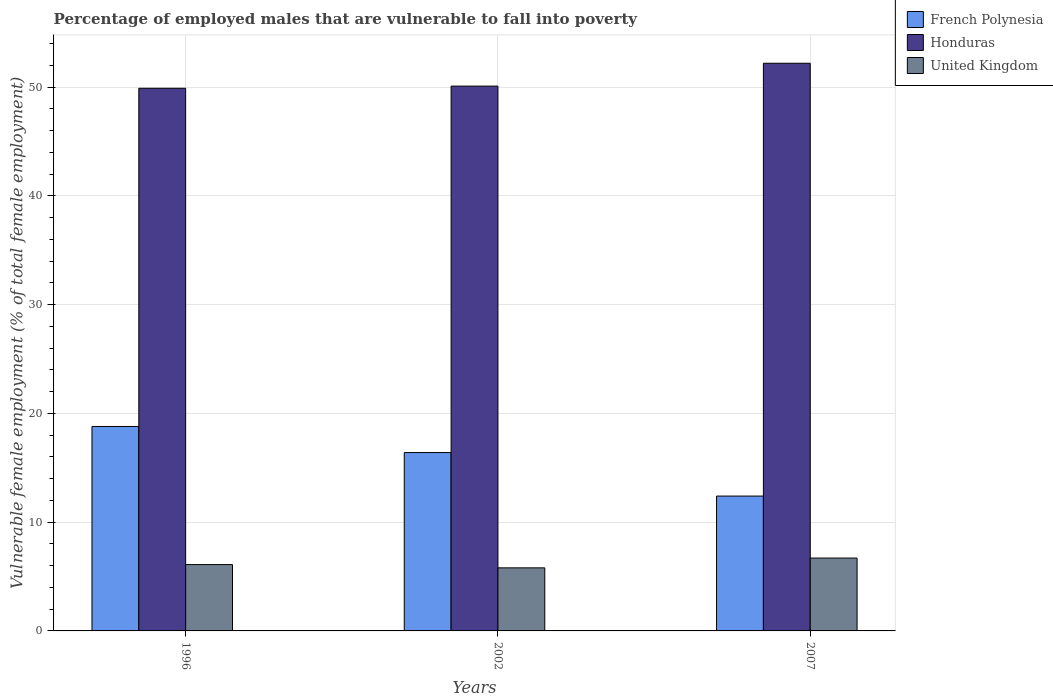How many groups of bars are there?
Your response must be concise. 3. Are the number of bars on each tick of the X-axis equal?
Make the answer very short. Yes. How many bars are there on the 2nd tick from the left?
Provide a short and direct response. 3. In how many cases, is the number of bars for a given year not equal to the number of legend labels?
Offer a terse response. 0. What is the percentage of employed males who are vulnerable to fall into poverty in Honduras in 2007?
Provide a short and direct response. 52.2. Across all years, what is the maximum percentage of employed males who are vulnerable to fall into poverty in Honduras?
Offer a terse response. 52.2. Across all years, what is the minimum percentage of employed males who are vulnerable to fall into poverty in French Polynesia?
Your answer should be compact. 12.4. In which year was the percentage of employed males who are vulnerable to fall into poverty in French Polynesia minimum?
Offer a very short reply. 2007. What is the total percentage of employed males who are vulnerable to fall into poverty in United Kingdom in the graph?
Your response must be concise. 18.6. What is the difference between the percentage of employed males who are vulnerable to fall into poverty in French Polynesia in 1996 and that in 2002?
Provide a succinct answer. 2.4. What is the difference between the percentage of employed males who are vulnerable to fall into poverty in French Polynesia in 2007 and the percentage of employed males who are vulnerable to fall into poverty in Honduras in 1996?
Your response must be concise. -37.5. What is the average percentage of employed males who are vulnerable to fall into poverty in French Polynesia per year?
Give a very brief answer. 15.87. In the year 1996, what is the difference between the percentage of employed males who are vulnerable to fall into poverty in United Kingdom and percentage of employed males who are vulnerable to fall into poverty in Honduras?
Ensure brevity in your answer.  -43.8. What is the ratio of the percentage of employed males who are vulnerable to fall into poverty in Honduras in 1996 to that in 2007?
Give a very brief answer. 0.96. Is the difference between the percentage of employed males who are vulnerable to fall into poverty in United Kingdom in 2002 and 2007 greater than the difference between the percentage of employed males who are vulnerable to fall into poverty in Honduras in 2002 and 2007?
Ensure brevity in your answer.  Yes. What is the difference between the highest and the second highest percentage of employed males who are vulnerable to fall into poverty in United Kingdom?
Offer a terse response. 0.6. What is the difference between the highest and the lowest percentage of employed males who are vulnerable to fall into poverty in French Polynesia?
Provide a succinct answer. 6.4. Is the sum of the percentage of employed males who are vulnerable to fall into poverty in Honduras in 1996 and 2007 greater than the maximum percentage of employed males who are vulnerable to fall into poverty in French Polynesia across all years?
Your response must be concise. Yes. What does the 2nd bar from the left in 1996 represents?
Your response must be concise. Honduras. What does the 2nd bar from the right in 2007 represents?
Give a very brief answer. Honduras. Is it the case that in every year, the sum of the percentage of employed males who are vulnerable to fall into poverty in French Polynesia and percentage of employed males who are vulnerable to fall into poverty in Honduras is greater than the percentage of employed males who are vulnerable to fall into poverty in United Kingdom?
Your answer should be compact. Yes. How many bars are there?
Make the answer very short. 9. Are all the bars in the graph horizontal?
Your answer should be compact. No. How many years are there in the graph?
Your answer should be very brief. 3. What is the difference between two consecutive major ticks on the Y-axis?
Offer a very short reply. 10. Are the values on the major ticks of Y-axis written in scientific E-notation?
Give a very brief answer. No. Does the graph contain grids?
Your response must be concise. Yes. Where does the legend appear in the graph?
Keep it short and to the point. Top right. How many legend labels are there?
Offer a terse response. 3. How are the legend labels stacked?
Keep it short and to the point. Vertical. What is the title of the graph?
Ensure brevity in your answer.  Percentage of employed males that are vulnerable to fall into poverty. What is the label or title of the Y-axis?
Keep it short and to the point. Vulnerable female employment (% of total female employment). What is the Vulnerable female employment (% of total female employment) of French Polynesia in 1996?
Offer a very short reply. 18.8. What is the Vulnerable female employment (% of total female employment) of Honduras in 1996?
Your answer should be very brief. 49.9. What is the Vulnerable female employment (% of total female employment) in United Kingdom in 1996?
Provide a succinct answer. 6.1. What is the Vulnerable female employment (% of total female employment) in French Polynesia in 2002?
Make the answer very short. 16.4. What is the Vulnerable female employment (% of total female employment) in Honduras in 2002?
Your answer should be very brief. 50.1. What is the Vulnerable female employment (% of total female employment) of United Kingdom in 2002?
Provide a short and direct response. 5.8. What is the Vulnerable female employment (% of total female employment) in French Polynesia in 2007?
Ensure brevity in your answer.  12.4. What is the Vulnerable female employment (% of total female employment) in Honduras in 2007?
Provide a succinct answer. 52.2. What is the Vulnerable female employment (% of total female employment) in United Kingdom in 2007?
Provide a short and direct response. 6.7. Across all years, what is the maximum Vulnerable female employment (% of total female employment) of French Polynesia?
Your answer should be very brief. 18.8. Across all years, what is the maximum Vulnerable female employment (% of total female employment) of Honduras?
Provide a succinct answer. 52.2. Across all years, what is the maximum Vulnerable female employment (% of total female employment) of United Kingdom?
Give a very brief answer. 6.7. Across all years, what is the minimum Vulnerable female employment (% of total female employment) of French Polynesia?
Give a very brief answer. 12.4. Across all years, what is the minimum Vulnerable female employment (% of total female employment) of Honduras?
Make the answer very short. 49.9. Across all years, what is the minimum Vulnerable female employment (% of total female employment) in United Kingdom?
Offer a terse response. 5.8. What is the total Vulnerable female employment (% of total female employment) of French Polynesia in the graph?
Provide a succinct answer. 47.6. What is the total Vulnerable female employment (% of total female employment) in Honduras in the graph?
Your answer should be very brief. 152.2. What is the difference between the Vulnerable female employment (% of total female employment) in French Polynesia in 1996 and that in 2002?
Make the answer very short. 2.4. What is the difference between the Vulnerable female employment (% of total female employment) in United Kingdom in 1996 and that in 2002?
Give a very brief answer. 0.3. What is the difference between the Vulnerable female employment (% of total female employment) of French Polynesia in 1996 and that in 2007?
Provide a succinct answer. 6.4. What is the difference between the Vulnerable female employment (% of total female employment) of United Kingdom in 2002 and that in 2007?
Offer a very short reply. -0.9. What is the difference between the Vulnerable female employment (% of total female employment) of French Polynesia in 1996 and the Vulnerable female employment (% of total female employment) of Honduras in 2002?
Ensure brevity in your answer.  -31.3. What is the difference between the Vulnerable female employment (% of total female employment) in Honduras in 1996 and the Vulnerable female employment (% of total female employment) in United Kingdom in 2002?
Your response must be concise. 44.1. What is the difference between the Vulnerable female employment (% of total female employment) in French Polynesia in 1996 and the Vulnerable female employment (% of total female employment) in Honduras in 2007?
Provide a succinct answer. -33.4. What is the difference between the Vulnerable female employment (% of total female employment) in Honduras in 1996 and the Vulnerable female employment (% of total female employment) in United Kingdom in 2007?
Provide a short and direct response. 43.2. What is the difference between the Vulnerable female employment (% of total female employment) in French Polynesia in 2002 and the Vulnerable female employment (% of total female employment) in Honduras in 2007?
Provide a short and direct response. -35.8. What is the difference between the Vulnerable female employment (% of total female employment) in French Polynesia in 2002 and the Vulnerable female employment (% of total female employment) in United Kingdom in 2007?
Your response must be concise. 9.7. What is the difference between the Vulnerable female employment (% of total female employment) in Honduras in 2002 and the Vulnerable female employment (% of total female employment) in United Kingdom in 2007?
Your answer should be compact. 43.4. What is the average Vulnerable female employment (% of total female employment) in French Polynesia per year?
Provide a succinct answer. 15.87. What is the average Vulnerable female employment (% of total female employment) of Honduras per year?
Keep it short and to the point. 50.73. What is the average Vulnerable female employment (% of total female employment) in United Kingdom per year?
Your answer should be compact. 6.2. In the year 1996, what is the difference between the Vulnerable female employment (% of total female employment) in French Polynesia and Vulnerable female employment (% of total female employment) in Honduras?
Your response must be concise. -31.1. In the year 1996, what is the difference between the Vulnerable female employment (% of total female employment) in French Polynesia and Vulnerable female employment (% of total female employment) in United Kingdom?
Provide a short and direct response. 12.7. In the year 1996, what is the difference between the Vulnerable female employment (% of total female employment) of Honduras and Vulnerable female employment (% of total female employment) of United Kingdom?
Offer a very short reply. 43.8. In the year 2002, what is the difference between the Vulnerable female employment (% of total female employment) of French Polynesia and Vulnerable female employment (% of total female employment) of Honduras?
Provide a short and direct response. -33.7. In the year 2002, what is the difference between the Vulnerable female employment (% of total female employment) in French Polynesia and Vulnerable female employment (% of total female employment) in United Kingdom?
Your answer should be very brief. 10.6. In the year 2002, what is the difference between the Vulnerable female employment (% of total female employment) in Honduras and Vulnerable female employment (% of total female employment) in United Kingdom?
Your answer should be compact. 44.3. In the year 2007, what is the difference between the Vulnerable female employment (% of total female employment) in French Polynesia and Vulnerable female employment (% of total female employment) in Honduras?
Your answer should be compact. -39.8. In the year 2007, what is the difference between the Vulnerable female employment (% of total female employment) in French Polynesia and Vulnerable female employment (% of total female employment) in United Kingdom?
Provide a succinct answer. 5.7. In the year 2007, what is the difference between the Vulnerable female employment (% of total female employment) of Honduras and Vulnerable female employment (% of total female employment) of United Kingdom?
Offer a very short reply. 45.5. What is the ratio of the Vulnerable female employment (% of total female employment) in French Polynesia in 1996 to that in 2002?
Offer a very short reply. 1.15. What is the ratio of the Vulnerable female employment (% of total female employment) of United Kingdom in 1996 to that in 2002?
Your response must be concise. 1.05. What is the ratio of the Vulnerable female employment (% of total female employment) of French Polynesia in 1996 to that in 2007?
Your answer should be compact. 1.52. What is the ratio of the Vulnerable female employment (% of total female employment) of Honduras in 1996 to that in 2007?
Offer a terse response. 0.96. What is the ratio of the Vulnerable female employment (% of total female employment) in United Kingdom in 1996 to that in 2007?
Keep it short and to the point. 0.91. What is the ratio of the Vulnerable female employment (% of total female employment) of French Polynesia in 2002 to that in 2007?
Provide a succinct answer. 1.32. What is the ratio of the Vulnerable female employment (% of total female employment) in Honduras in 2002 to that in 2007?
Ensure brevity in your answer.  0.96. What is the ratio of the Vulnerable female employment (% of total female employment) of United Kingdom in 2002 to that in 2007?
Make the answer very short. 0.87. What is the difference between the highest and the second highest Vulnerable female employment (% of total female employment) of United Kingdom?
Your response must be concise. 0.6. What is the difference between the highest and the lowest Vulnerable female employment (% of total female employment) in Honduras?
Provide a succinct answer. 2.3. 